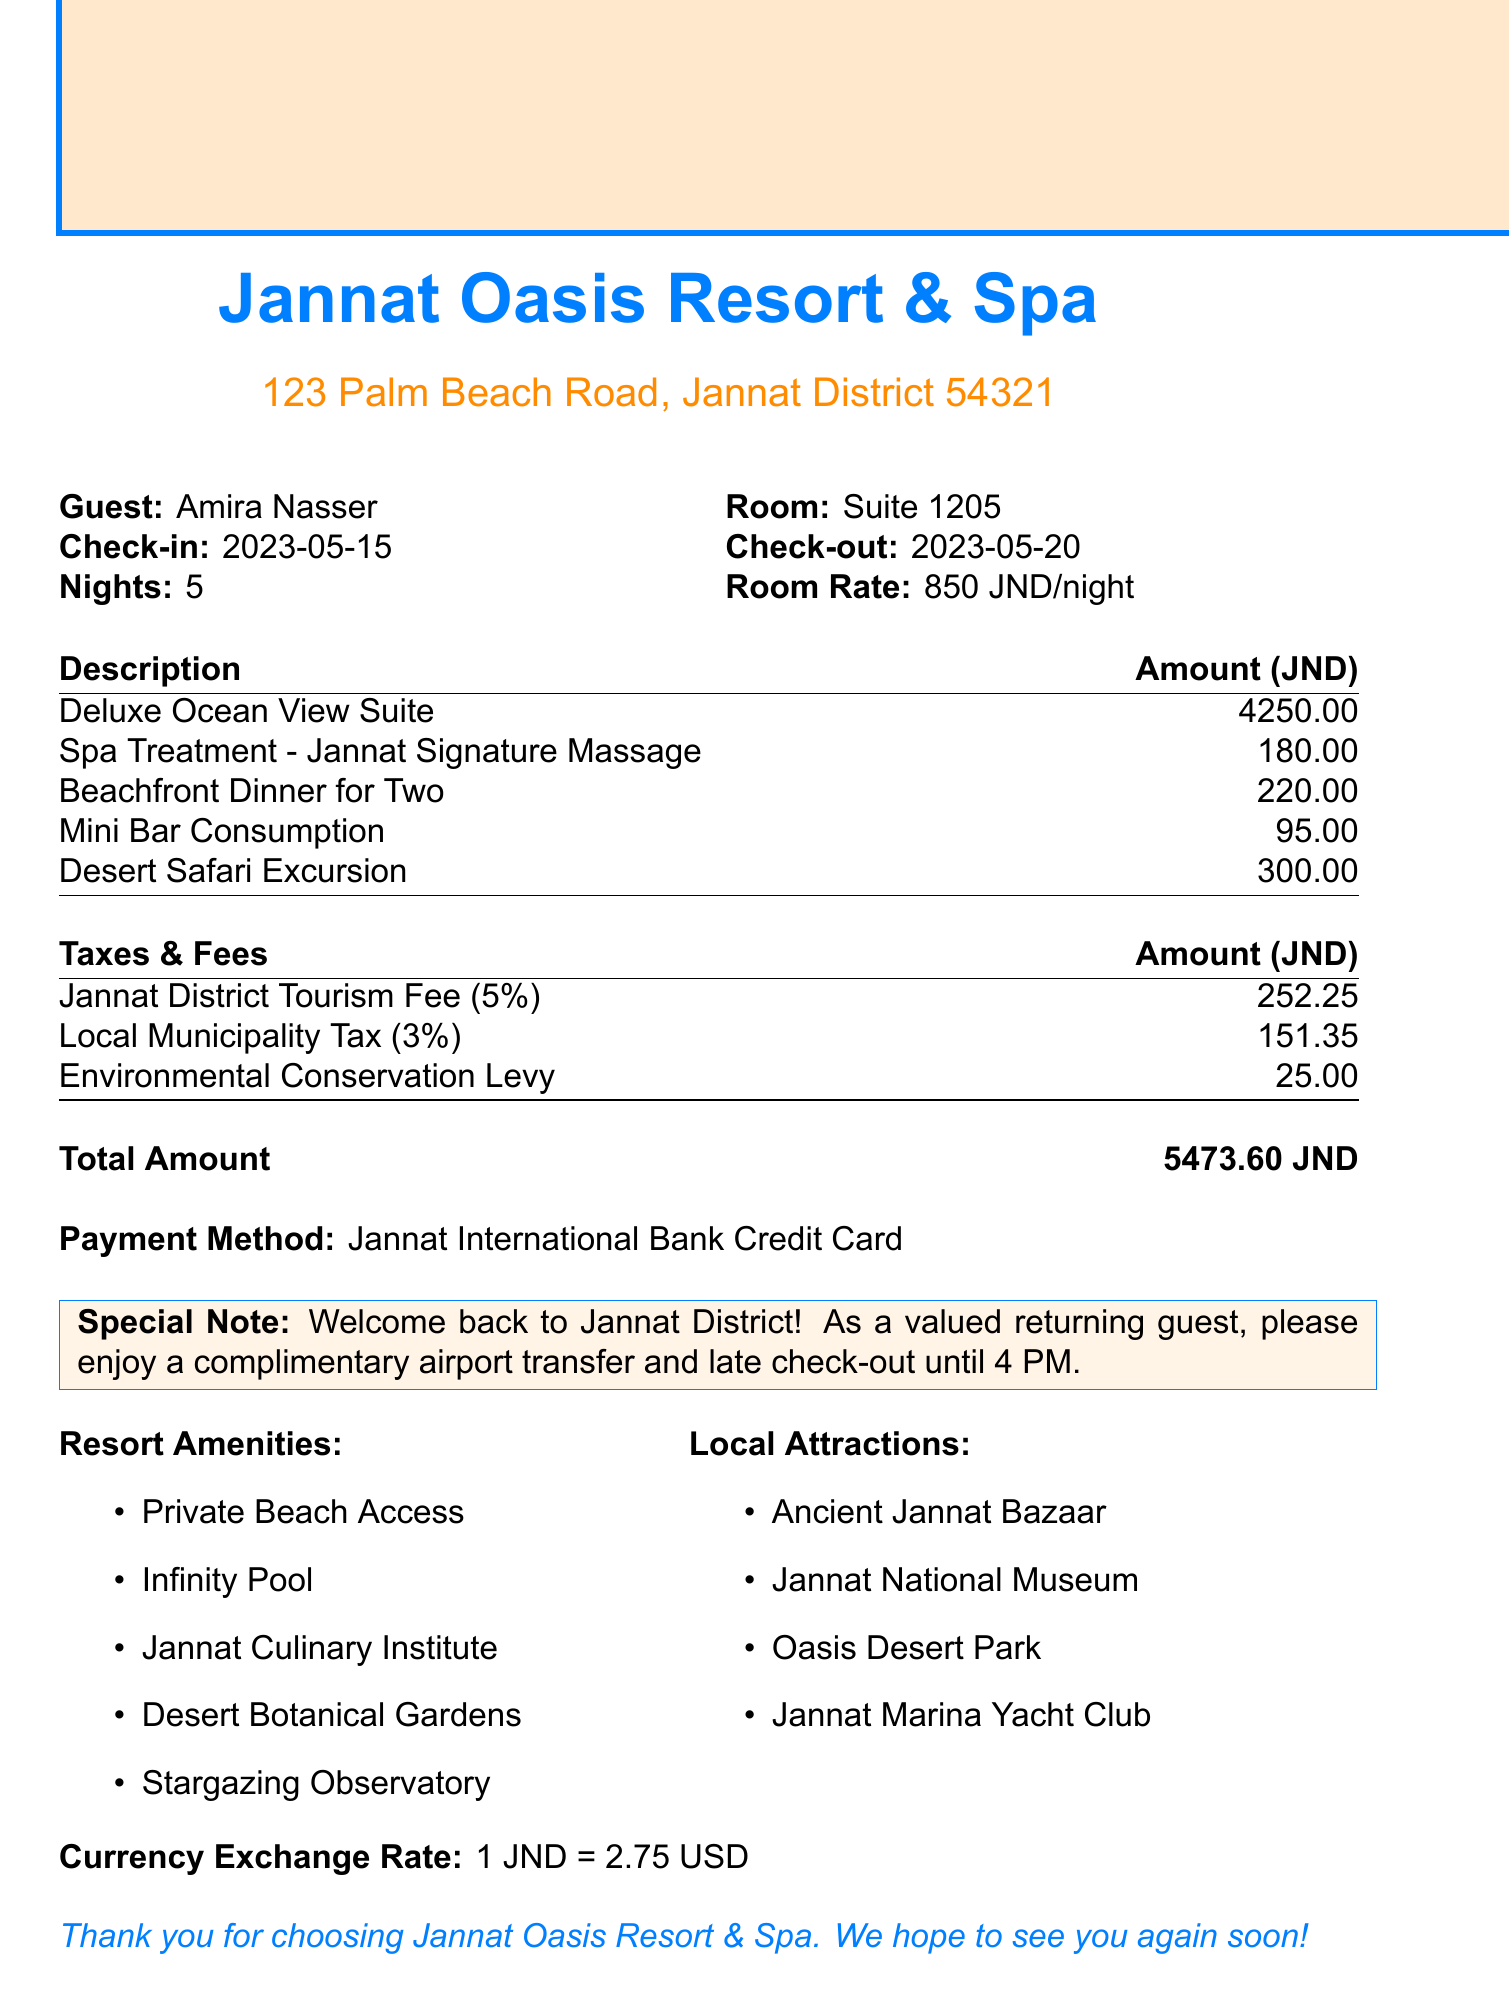What is the guest's name? The guest's name is listed on the receipt.
Answer: Amira Nasser What is the room number? The room number is mentioned in the document.
Answer: Suite 1205 How many nights did the guest stay? The number of nights stayed is specified in the document.
Answer: 5 What is the total amount charged? The total amount is provided at the end of the charges section.
Answer: 5473.60 JND What is the amount for the Deluxe Ocean View Suite? This information is available in the charges table.
Answer: 4250.00 What is the Jannat District Tourism Fee amount? The specific tax can be found in the taxes section of the document.
Answer: 252.25 How much is the Local Municipality Tax? This tax amount is listed along with other charges.
Answer: 151.35 What special note is mentioned for the guest? This note is included in the document to show appreciation for the returning guest.
Answer: Welcome back to Jannat District! What amenities does the resort offer? The list of amenities is provided in the document.
Answer: Private Beach Access, Infinity Pool, Jannat Culinary Institute, Desert Botanical Gardens, Stargazing Observatory What local attractions are mentioned? These attractions are listed in the document for guests' information.
Answer: Ancient Jannat Bazaar, Jannat National Museum, Oasis Desert Park, Jannat Marina Yacht Club 